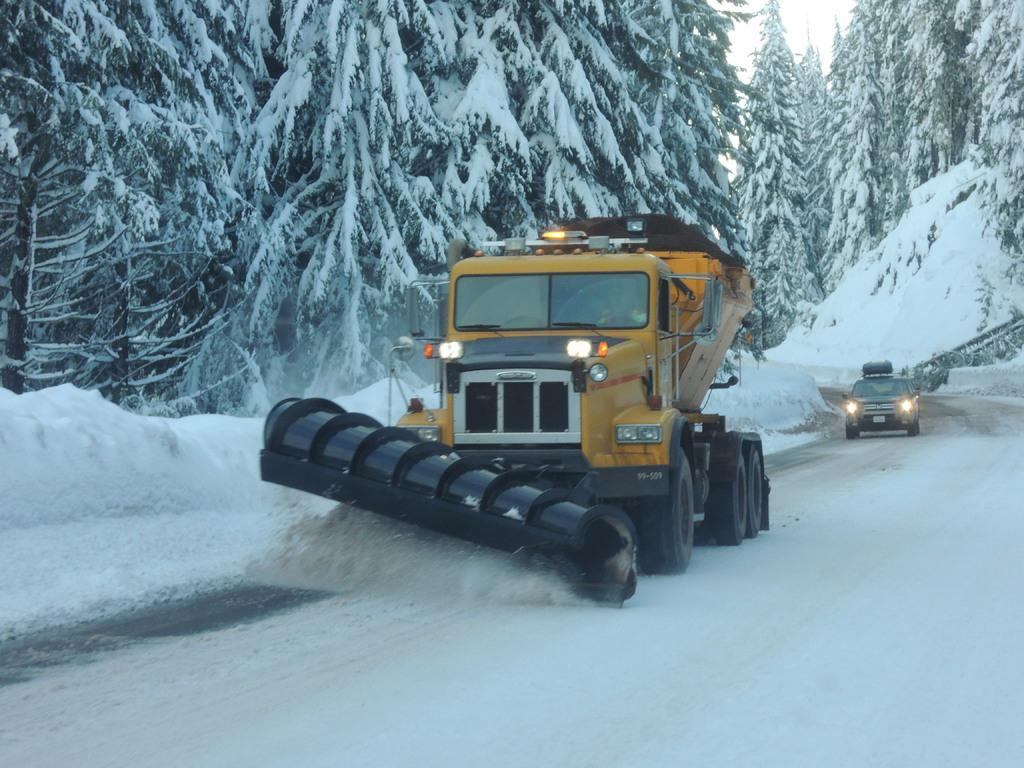What is covering the ground in the front of the image? There is snow on the ground in the front of the image. What is happening in the center of the image? Vehicles are moving on the road in the center of the image. What can be seen in the background of the image? There are trees in the background of the image. Is there any snow on the trees in the background? Yes, snow is present on the trees in the background. What type of drink is being served in the image? There is no drink being served in the image; it features snow, vehicles, and trees. What color is the polish on the trees in the image? There is no mention of polish on the trees in the image; they are covered in snow. 